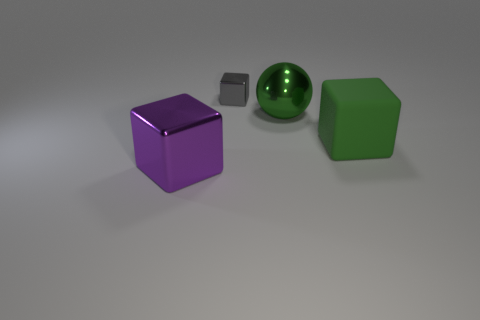Add 1 gray cylinders. How many objects exist? 5 Subtract all cubes. How many objects are left? 1 Subtract all cyan things. Subtract all rubber cubes. How many objects are left? 3 Add 4 big green metal balls. How many big green metal balls are left? 5 Add 4 big purple metallic blocks. How many big purple metallic blocks exist? 5 Subtract 0 blue spheres. How many objects are left? 4 